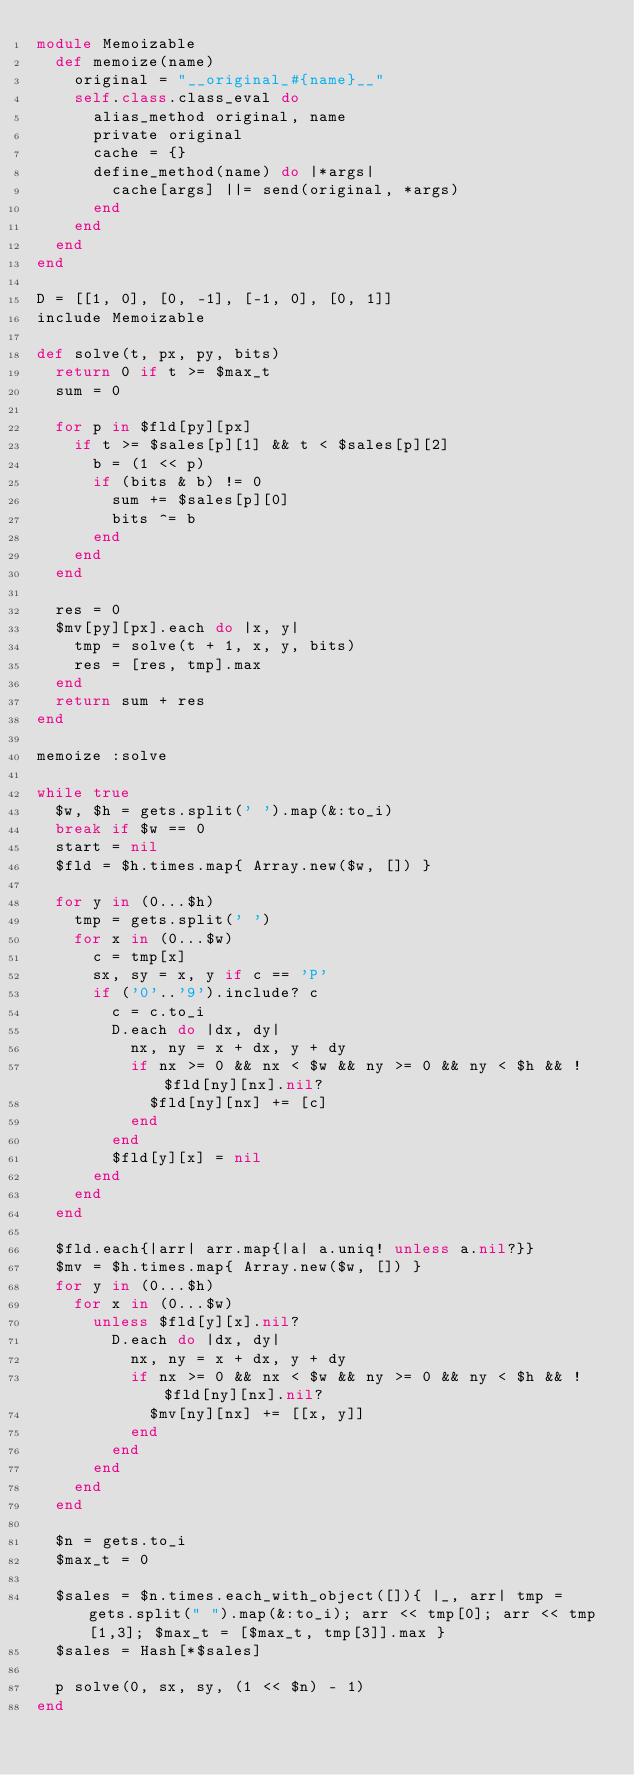<code> <loc_0><loc_0><loc_500><loc_500><_Ruby_>module Memoizable
  def memoize(name)
    original = "__original_#{name}__"
    self.class.class_eval do
      alias_method original, name
      private original
      cache = {}
      define_method(name) do |*args|
        cache[args] ||= send(original, *args)
      end
    end
  end
end

D = [[1, 0], [0, -1], [-1, 0], [0, 1]]
include Memoizable

def solve(t, px, py, bits)
  return 0 if t >= $max_t 
  sum = 0
 
  for p in $fld[py][px]
    if t >= $sales[p][1] && t < $sales[p][2]
      b = (1 << p)
      if (bits & b) != 0
        sum += $sales[p][0]
        bits ^= b
      end
    end
  end
 
  res = 0
  $mv[py][px].each do |x, y|
    tmp = solve(t + 1, x, y, bits)
    res = [res, tmp].max
  end
  return sum + res
end

memoize :solve

while true
  $w, $h = gets.split(' ').map(&:to_i)
  break if $w == 0
  start = nil
  $fld = $h.times.map{ Array.new($w, []) }
    
  for y in (0...$h)
    tmp = gets.split(' ')
    for x in (0...$w)
      c = tmp[x]
      sx, sy = x, y if c == 'P'
      if ('0'..'9').include? c
        c = c.to_i
        D.each do |dx, dy|
          nx, ny = x + dx, y + dy
          if nx >= 0 && nx < $w && ny >= 0 && ny < $h && !$fld[ny][nx].nil?
            $fld[ny][nx] += [c]
          end
        end
        $fld[y][x] = nil
      end
    end
  end
  
  $fld.each{|arr| arr.map{|a| a.uniq! unless a.nil?}}
  $mv = $h.times.map{ Array.new($w, []) }
  for y in (0...$h)
    for x in (0...$w)
      unless $fld[y][x].nil?
        D.each do |dx, dy|
          nx, ny = x + dx, y + dy
          if nx >= 0 && nx < $w && ny >= 0 && ny < $h && !$fld[ny][nx].nil?
            $mv[ny][nx] += [[x, y]]
          end
        end
      end
    end
  end

  $n = gets.to_i
  $max_t = 0

  $sales = $n.times.each_with_object([]){ |_, arr| tmp = gets.split(" ").map(&:to_i); arr << tmp[0]; arr << tmp[1,3]; $max_t = [$max_t, tmp[3]].max }
  $sales = Hash[*$sales]
 
  p solve(0, sx, sy, (1 << $n) - 1)
end</code> 